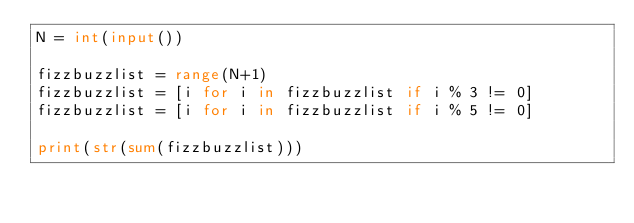Convert code to text. <code><loc_0><loc_0><loc_500><loc_500><_Python_>N = int(input())

fizzbuzzlist = range(N+1)
fizzbuzzlist = [i for i in fizzbuzzlist if i % 3 != 0]
fizzbuzzlist = [i for i in fizzbuzzlist if i % 5 != 0]

print(str(sum(fizzbuzzlist)))</code> 